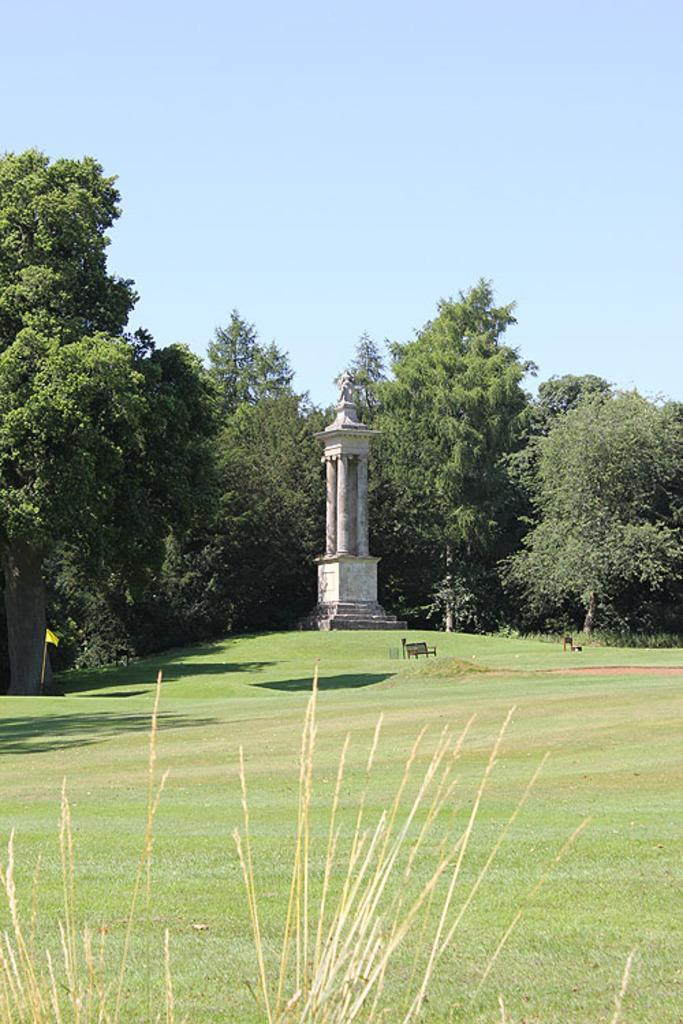What type of vegetation is present in the image? There is grass in the image. What structure can be seen in the image? There is a monument in the image. What other natural elements are present in the image? There are trees in the image. What can be seen in the distance in the image? The sky is visible in the background of the image. What type of guitar is the person playing in the image? There is no person or guitar present in the image; it features grass, a monument, trees, and the sky. Can you see a hat on the monument in the image? There is no hat present on the monument or anywhere else in the image. 